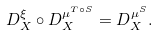Convert formula to latex. <formula><loc_0><loc_0><loc_500><loc_500>D ^ { \xi } _ { X } \circ D ^ { \mu ^ { T \circ S } } _ { X } = D ^ { \mu ^ { S } } _ { X } .</formula> 